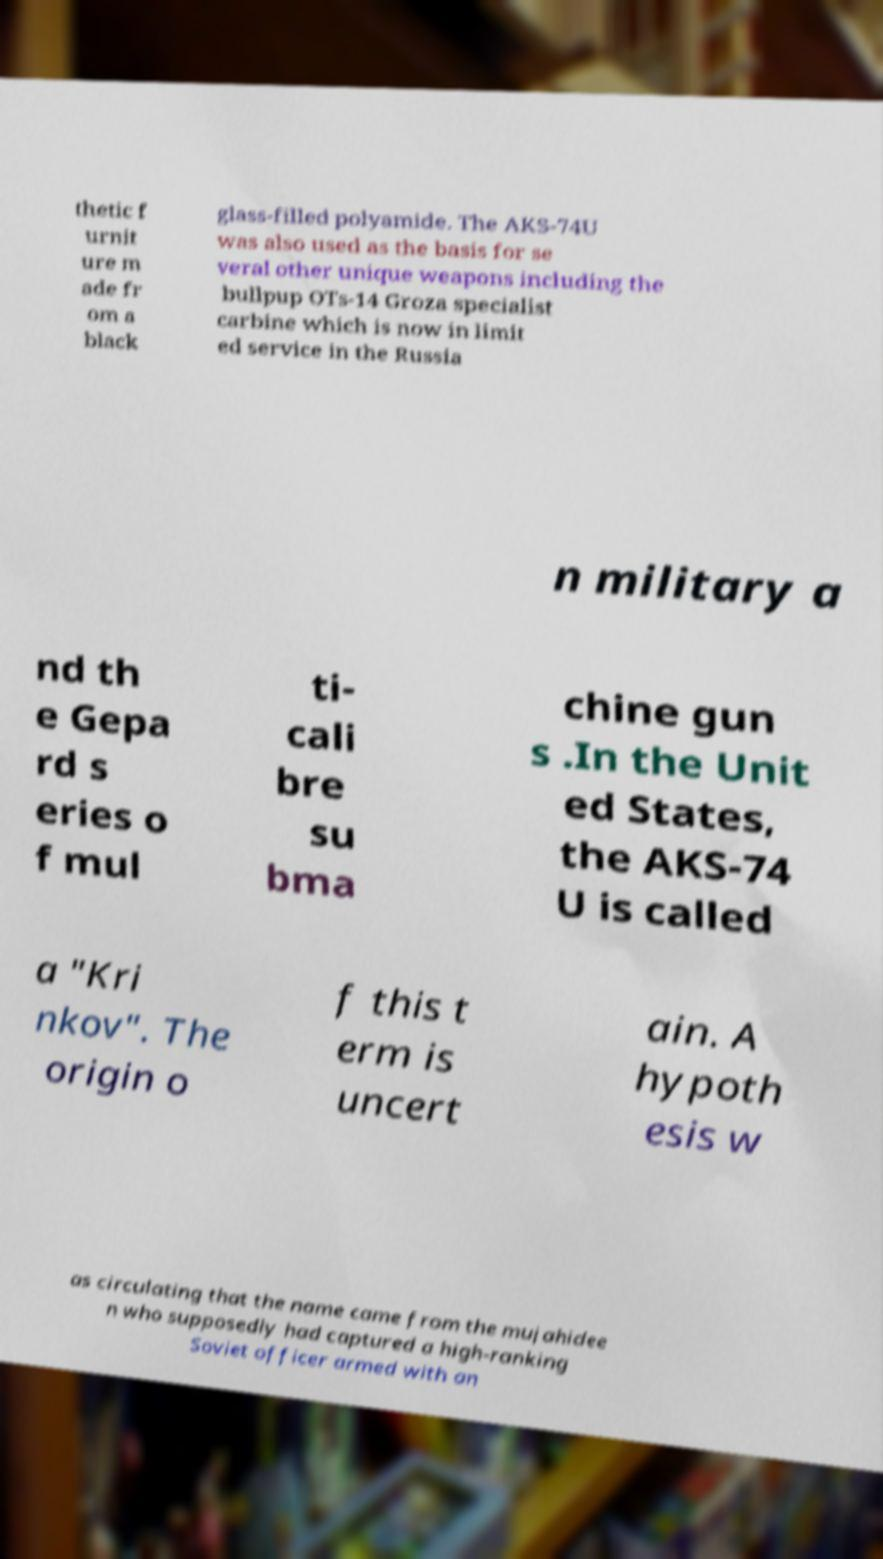Could you assist in decoding the text presented in this image and type it out clearly? thetic f urnit ure m ade fr om a black glass-filled polyamide. The AKS-74U was also used as the basis for se veral other unique weapons including the bullpup OTs-14 Groza specialist carbine which is now in limit ed service in the Russia n military a nd th e Gepa rd s eries o f mul ti- cali bre su bma chine gun s .In the Unit ed States, the AKS-74 U is called a "Kri nkov". The origin o f this t erm is uncert ain. A hypoth esis w as circulating that the name came from the mujahidee n who supposedly had captured a high-ranking Soviet officer armed with an 